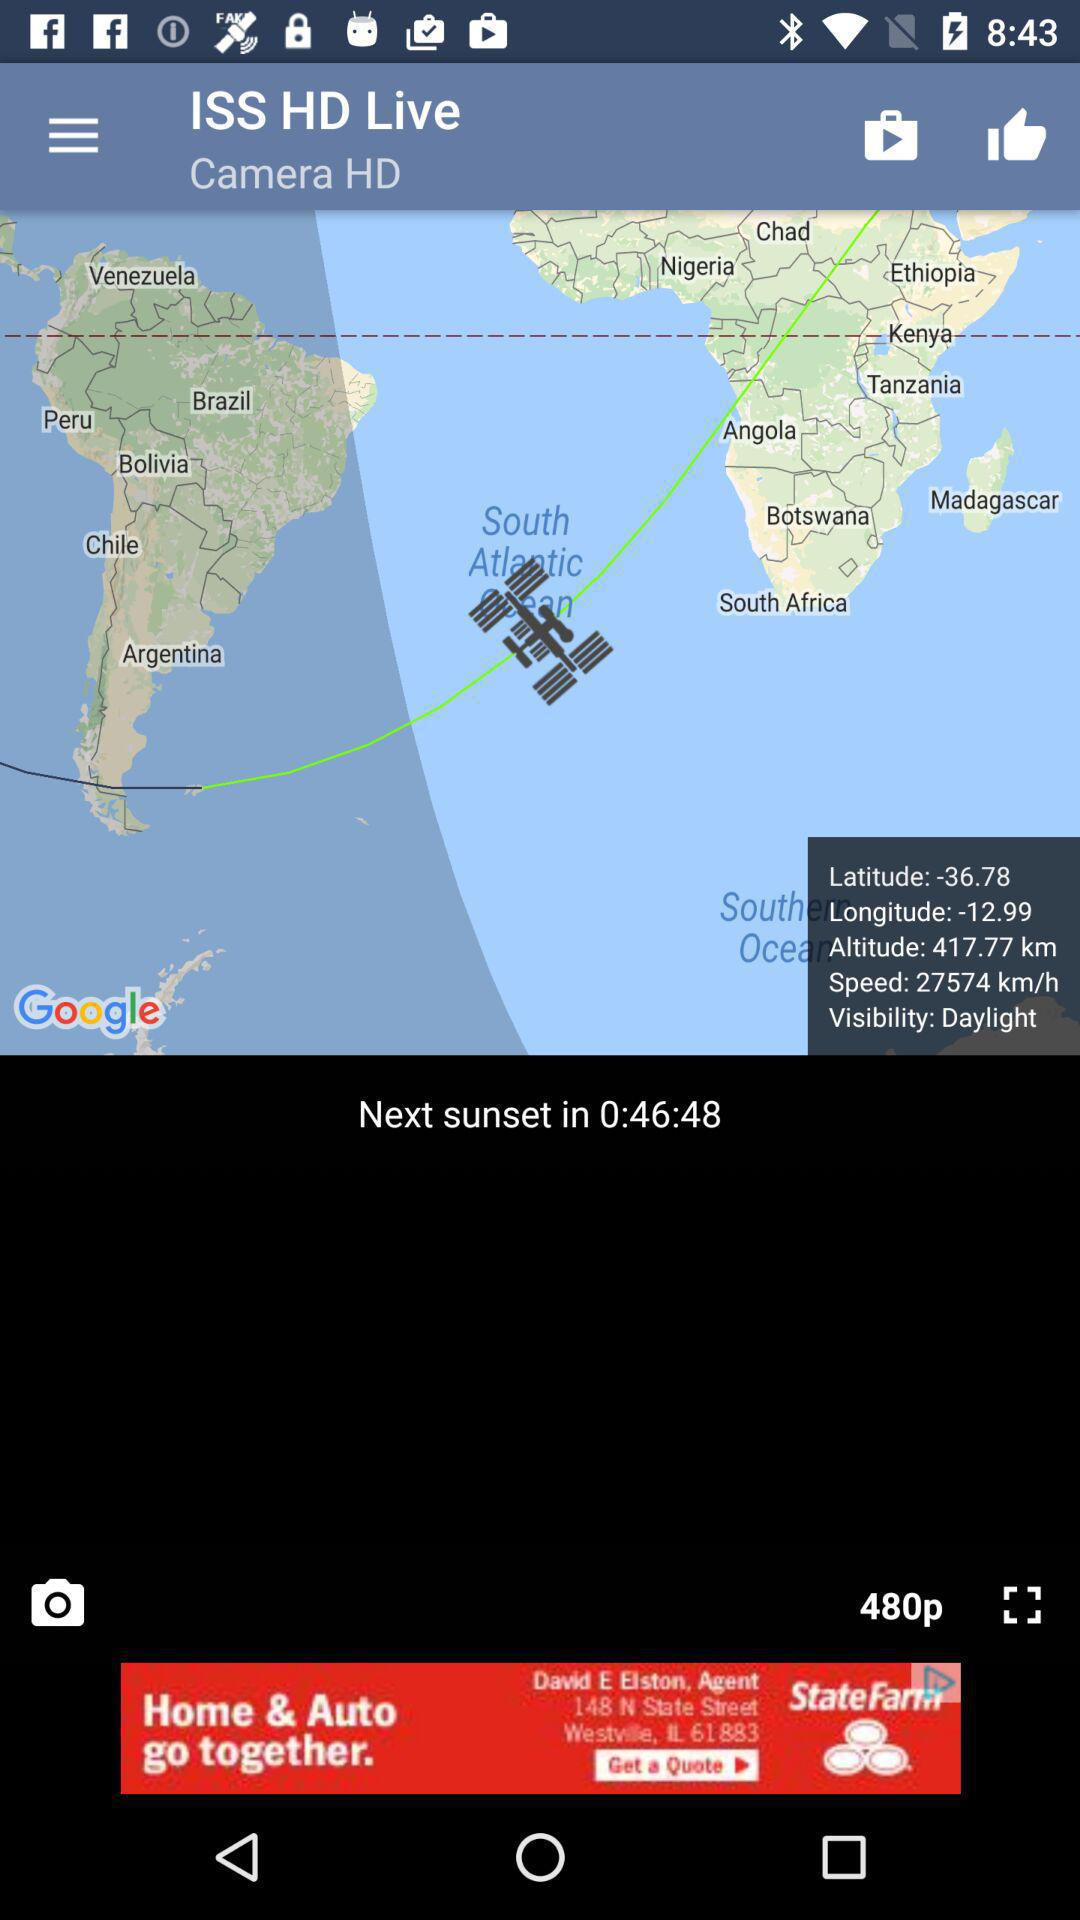What's the speed? The speed is 27574 km/h. 